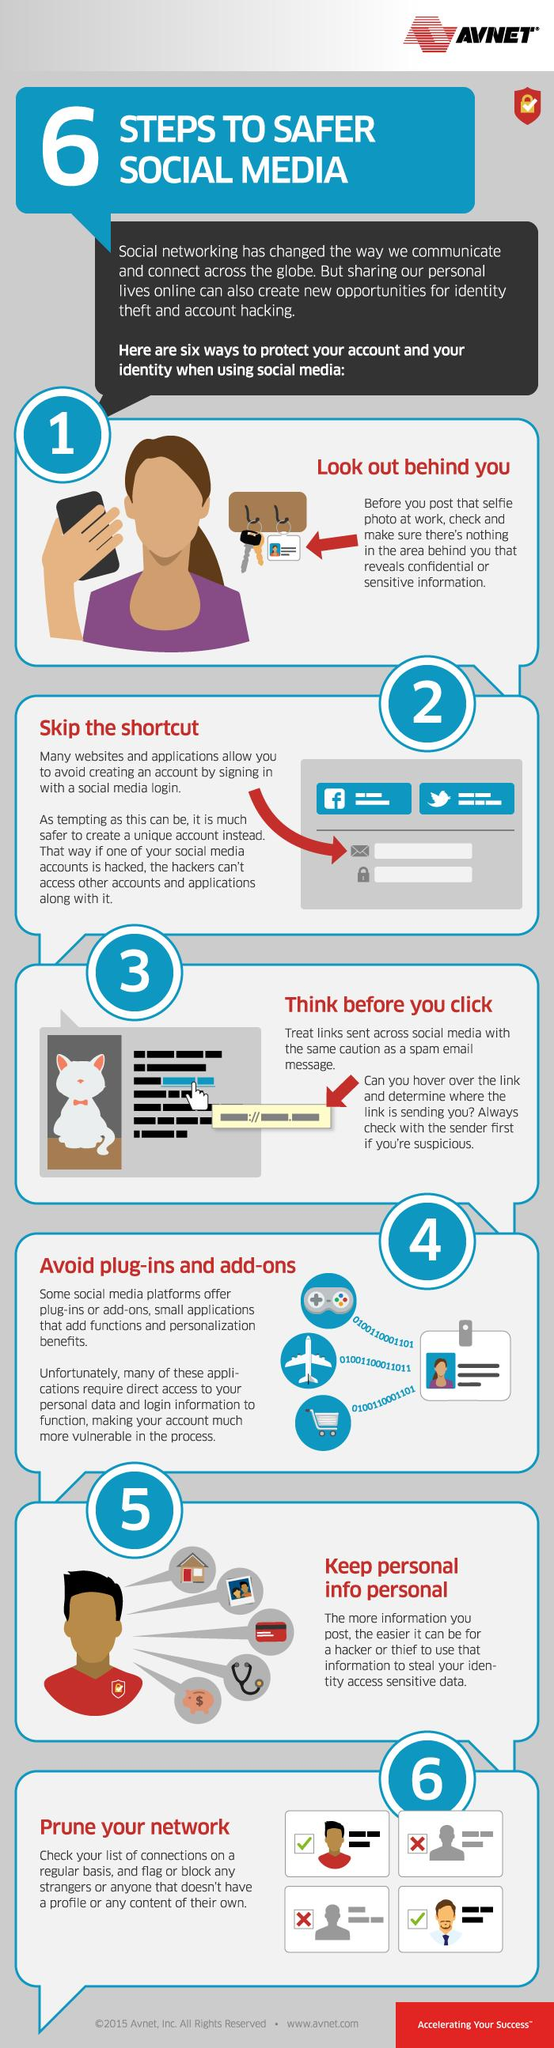List a handful of essential elements in this visual. I am not sure what you are asking for. Could you please provide more context or clarify your question? The color in which the phrase "prune your network" is written is red. The sixth step recommended in the infographic to protect user identity on social media is to prune your network, which involves removing unnecessary connections to maintain privacy and security. In the 6th step graphic, there are two icons of a cross. The color of the aero plane icon is white. 